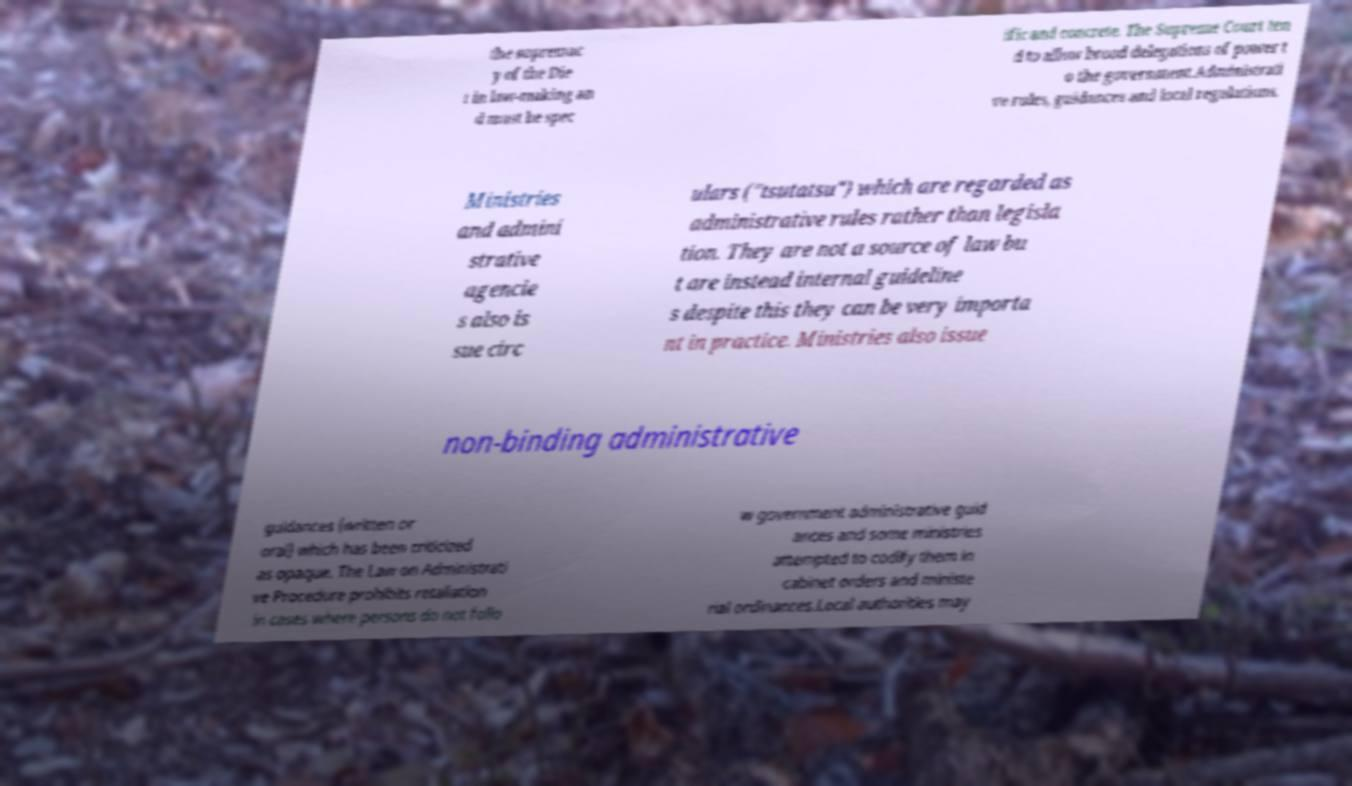For documentation purposes, I need the text within this image transcribed. Could you provide that? the supremac y of the Die t in law-making an d must be spec ific and concrete. The Supreme Court ten d to allow broad delegations of power t o the government.Administrati ve rules, guidances and local regulations. Ministries and admini strative agencie s also is sue circ ulars ("tsutatsu") which are regarded as administrative rules rather than legisla tion. They are not a source of law bu t are instead internal guideline s despite this they can be very importa nt in practice. Ministries also issue non-binding administrative guidances (written or oral) which has been criticized as opaque. The Law on Administrati ve Procedure prohibits retaliation in cases where persons do not follo w government administrative guid ances and some ministries attempted to codify them in cabinet orders and ministe rial ordinances.Local authorities may 